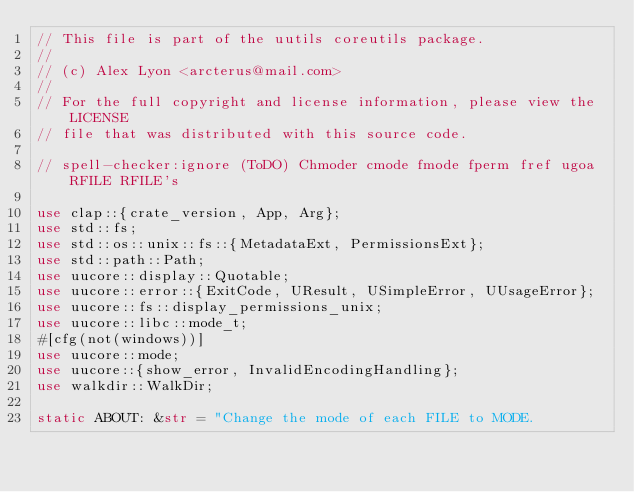<code> <loc_0><loc_0><loc_500><loc_500><_Rust_>// This file is part of the uutils coreutils package.
//
// (c) Alex Lyon <arcterus@mail.com>
//
// For the full copyright and license information, please view the LICENSE
// file that was distributed with this source code.

// spell-checker:ignore (ToDO) Chmoder cmode fmode fperm fref ugoa RFILE RFILE's

use clap::{crate_version, App, Arg};
use std::fs;
use std::os::unix::fs::{MetadataExt, PermissionsExt};
use std::path::Path;
use uucore::display::Quotable;
use uucore::error::{ExitCode, UResult, USimpleError, UUsageError};
use uucore::fs::display_permissions_unix;
use uucore::libc::mode_t;
#[cfg(not(windows))]
use uucore::mode;
use uucore::{show_error, InvalidEncodingHandling};
use walkdir::WalkDir;

static ABOUT: &str = "Change the mode of each FILE to MODE.</code> 